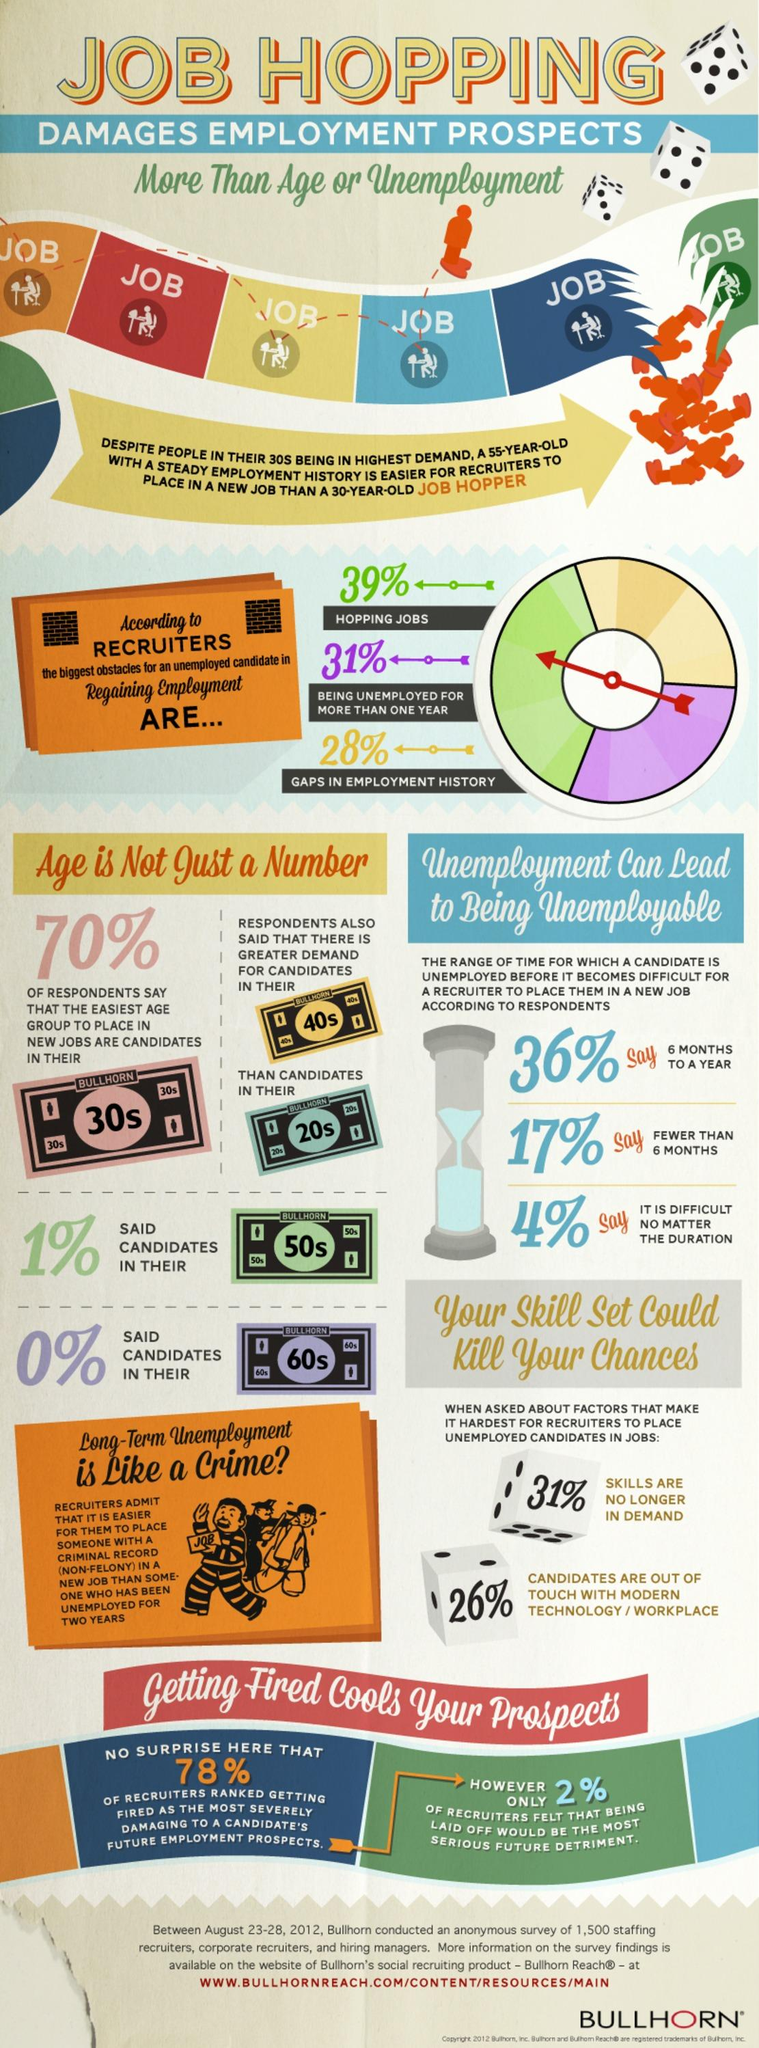Draw attention to some important aspects in this diagram. According to the Bullhorn survey, 28% of recruiters believe that gaps in employment history is the biggest obstacle for an unemployed candidate in regaining employment. According to the Bullhorn survey, 31% of recruiters believe that being unemployed for more than one year is the biggest obstacle for an unemployed candidate in regaining employment. According to the Bullhorn survey conducted, the demand for candidates in the 40s age group is particularly high in the job market. According to the Bullhorn survey, 74% of candidates are not out of touch with modern technology and the workplace. According to the Bullhorn survey, 39% of recruiters believe that job hopping is the biggest obstacle for an unemployed candidate in regaining employment. 